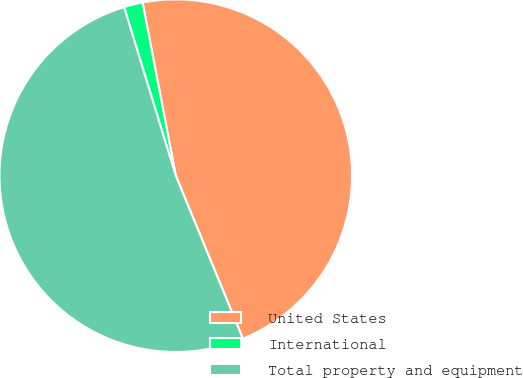<chart> <loc_0><loc_0><loc_500><loc_500><pie_chart><fcel>United States<fcel>International<fcel>Total property and equipment<nl><fcel>46.8%<fcel>1.72%<fcel>51.48%<nl></chart> 